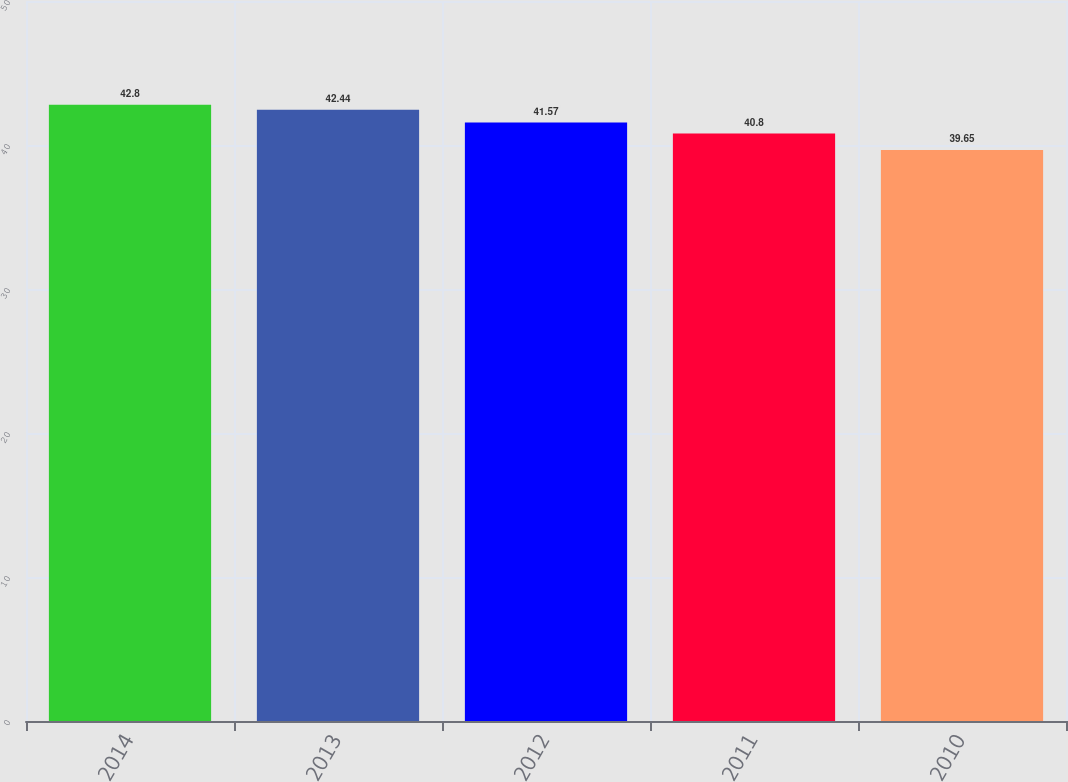<chart> <loc_0><loc_0><loc_500><loc_500><bar_chart><fcel>2014<fcel>2013<fcel>2012<fcel>2011<fcel>2010<nl><fcel>42.8<fcel>42.44<fcel>41.57<fcel>40.8<fcel>39.65<nl></chart> 